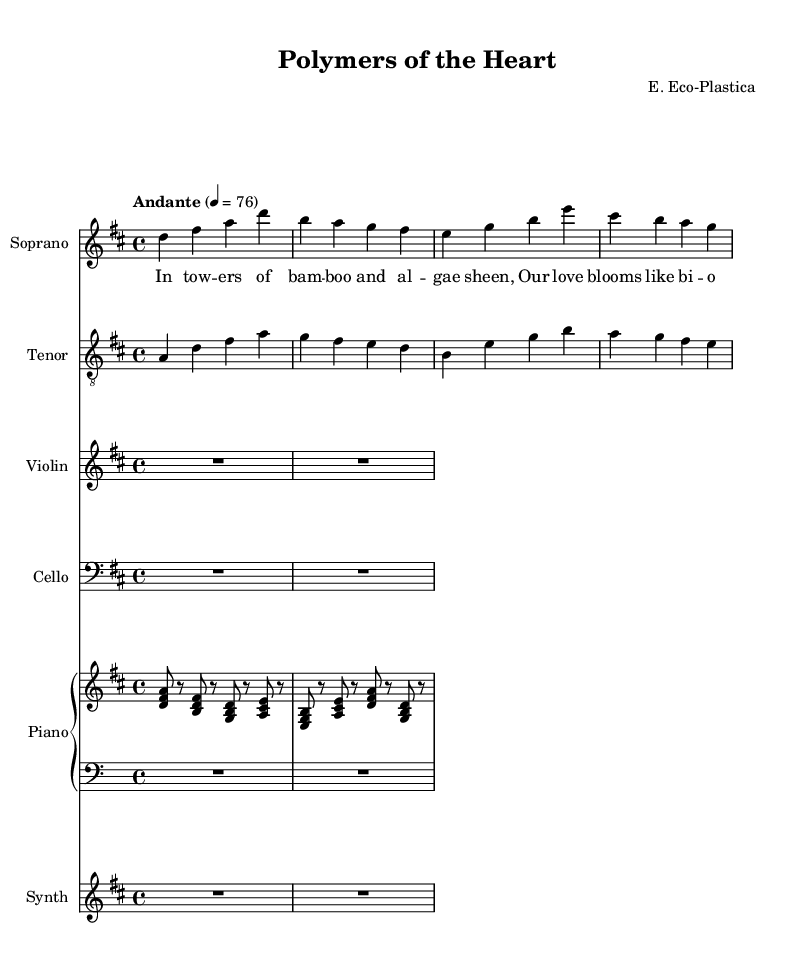What is the key signature of this music? The key signature is indicated by the presence of two sharps (F# and C#) in the signature area, which corresponds to D major.
Answer: D major What is the time signature used in this score? The time signature appears at the beginning of the score, indicated by the fraction 4/4, meaning there are four beats in each measure and the quarter note gets the beat.
Answer: 4/4 What is the tempo marking for this piece? The tempo marking, found at the start of the score, indicates the speed of the music with "Andante" followed by a metronome marking of 76, indicating a moderately slow pace.
Answer: Andante 76 How many voices are used in this opera piece? By examining the score, there are two distinct vocal parts labeled as "Soprano" and "Tenor," indicating a total of two voices.
Answer: Two What innovative material is referenced in the lyrics? The lyrics mention "bio-plastic," which is an innovative material that aligns with eco-friendly trends and sustainability within the context of the opera.
Answer: Bio-plastic Which instrument plays the accompaniment in the score? The piano part, indicated by the staff labeled "Piano," serves as the primary accompaniment for the singers and is visible in the score.
Answer: Piano What does the term 'synth' refer to in this music? The term 'synth' refers to a synthesizer, which is an electronic instrument used in this score to provide additional harmonic and textural support, indicated by the staff labeled "Synth."
Answer: Synthesizer 